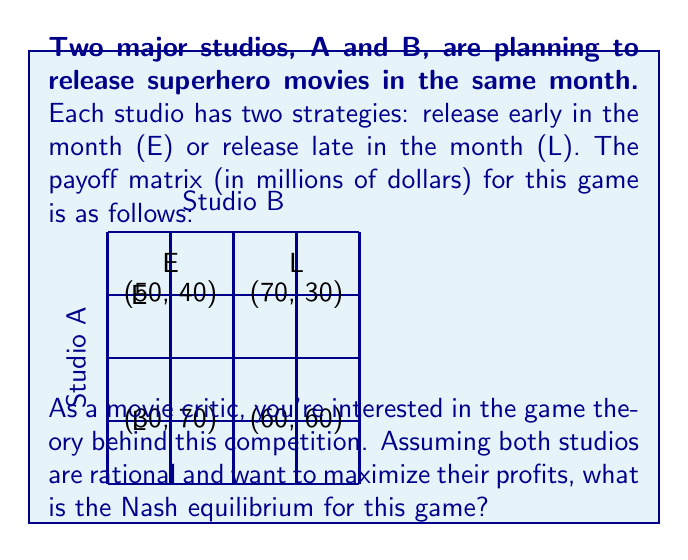What is the answer to this math problem? To find the Nash equilibrium, we need to analyze each studio's best response to the other studio's strategy:

1. For Studio A:
   - If B chooses E: A's best response is L (70 > 50)
   - If B chooses L: A's best response is L (60 > 30)

2. For Studio B:
   - If A chooses E: B's best response is L (70 > 40)
   - If A chooses L: B's best response is E (30 > 60)

A Nash equilibrium occurs when neither player can unilaterally improve their payoff by changing their strategy.

Looking at the best responses, we can see that:
- When A chooses L, B's best response is E
- When B chooses E, A's best response is L

This combination (A: L, B: E) is stable, as neither studio has an incentive to change their strategy unilaterally. 

Therefore, the Nash equilibrium for this game is (L, E), where Studio A releases late and Studio B releases early.

The payoff for this equilibrium is:
$$\text{Payoff} = (70, 30)$$

This means Studio A earns $70 million, while Studio B earns $30 million.
Answer: (L, E) with payoff (70, 30) 